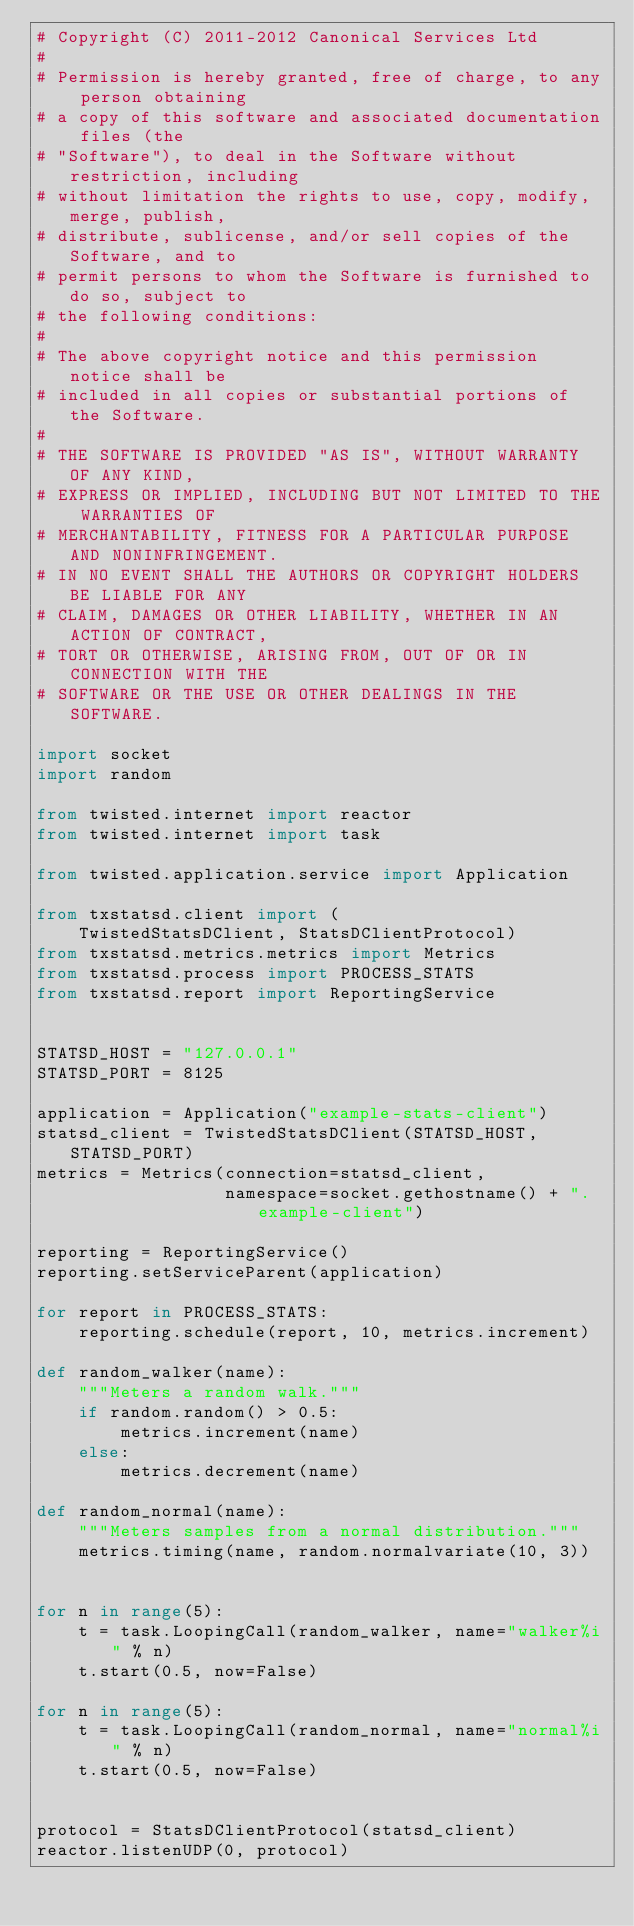Convert code to text. <code><loc_0><loc_0><loc_500><loc_500><_Python_># Copyright (C) 2011-2012 Canonical Services Ltd
#
# Permission is hereby granted, free of charge, to any person obtaining
# a copy of this software and associated documentation files (the
# "Software"), to deal in the Software without restriction, including
# without limitation the rights to use, copy, modify, merge, publish,
# distribute, sublicense, and/or sell copies of the Software, and to
# permit persons to whom the Software is furnished to do so, subject to
# the following conditions:
#
# The above copyright notice and this permission notice shall be
# included in all copies or substantial portions of the Software.
#
# THE SOFTWARE IS PROVIDED "AS IS", WITHOUT WARRANTY OF ANY KIND,
# EXPRESS OR IMPLIED, INCLUDING BUT NOT LIMITED TO THE WARRANTIES OF
# MERCHANTABILITY, FITNESS FOR A PARTICULAR PURPOSE AND NONINFRINGEMENT.
# IN NO EVENT SHALL THE AUTHORS OR COPYRIGHT HOLDERS BE LIABLE FOR ANY
# CLAIM, DAMAGES OR OTHER LIABILITY, WHETHER IN AN ACTION OF CONTRACT,
# TORT OR OTHERWISE, ARISING FROM, OUT OF OR IN CONNECTION WITH THE
# SOFTWARE OR THE USE OR OTHER DEALINGS IN THE SOFTWARE.

import socket
import random

from twisted.internet import reactor
from twisted.internet import task

from twisted.application.service import Application

from txstatsd.client import (
    TwistedStatsDClient, StatsDClientProtocol)
from txstatsd.metrics.metrics import Metrics
from txstatsd.process import PROCESS_STATS
from txstatsd.report import ReportingService


STATSD_HOST = "127.0.0.1"
STATSD_PORT = 8125

application = Application("example-stats-client")
statsd_client = TwistedStatsDClient(STATSD_HOST, STATSD_PORT)
metrics = Metrics(connection=statsd_client,
                  namespace=socket.gethostname() + ".example-client")

reporting = ReportingService()
reporting.setServiceParent(application)

for report in PROCESS_STATS:
    reporting.schedule(report, 10, metrics.increment)

def random_walker(name):
    """Meters a random walk."""
    if random.random() > 0.5:
        metrics.increment(name)
    else:
        metrics.decrement(name)

def random_normal(name):
    """Meters samples from a normal distribution."""
    metrics.timing(name, random.normalvariate(10, 3))


for n in range(5):
    t = task.LoopingCall(random_walker, name="walker%i" % n)
    t.start(0.5, now=False)

for n in range(5):
    t = task.LoopingCall(random_normal, name="normal%i" % n)
    t.start(0.5, now=False)


protocol = StatsDClientProtocol(statsd_client)
reactor.listenUDP(0, protocol)
</code> 